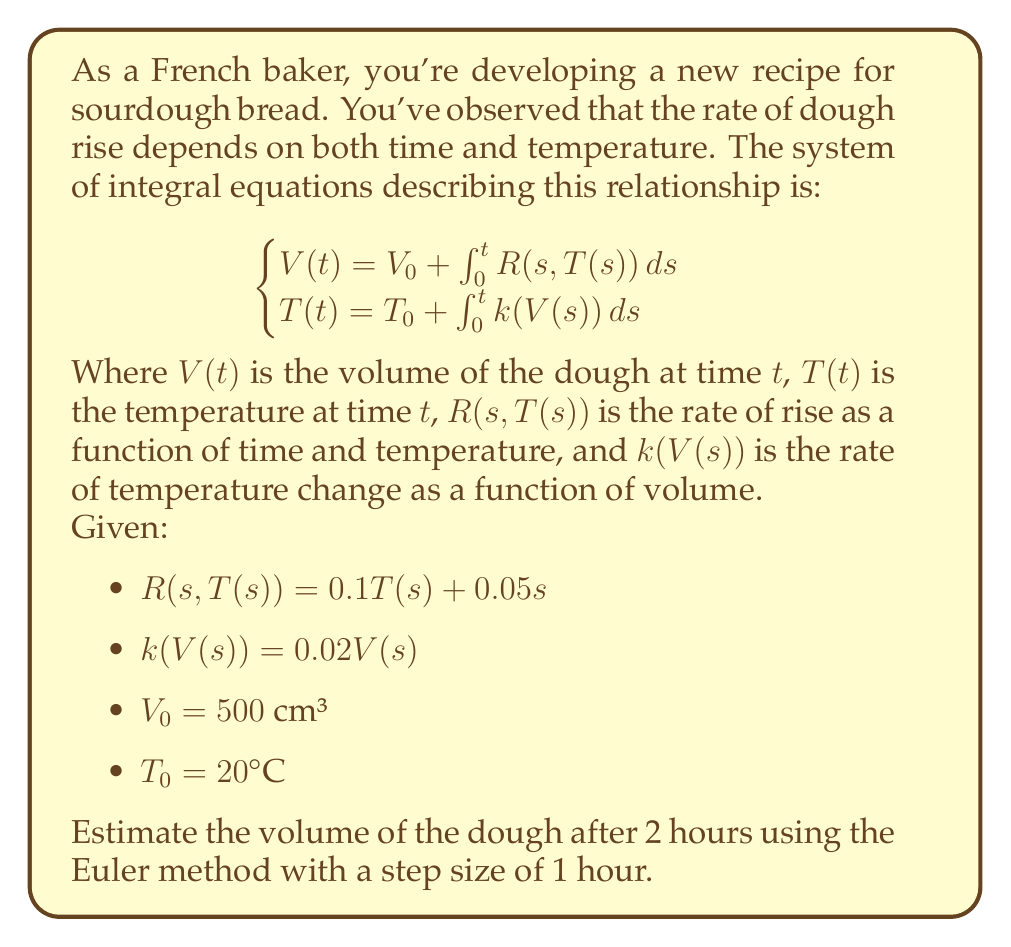Could you help me with this problem? To solve this problem, we'll use the Euler method to approximate the solution of the system of integral equations. We'll proceed step by step:

1) The Euler method for a system of equations takes the form:
   $$\begin{cases}
   V_{n+1} = V_n + h \cdot R(t_n, T_n) \\
   T_{n+1} = T_n + h \cdot k(V_n)
   \end{cases}$$
   where $h$ is the step size (1 hour in this case).

2) We start with the initial conditions:
   $V_0 = 500$ cm³
   $T_0 = 20°C$

3) For the first step ($n = 0$, $t = 0$ to $t = 1$):
   $$\begin{align*}
   V_1 &= V_0 + h \cdot R(0, T_0) \\
       &= 500 + 1 \cdot (0.1 \cdot 20 + 0.05 \cdot 0) \\
       &= 500 + 2 = 502 \text{ cm³}
   \end{align*}$$

   $$\begin{align*}
   T_1 &= T_0 + h \cdot k(V_0) \\
       &= 20 + 1 \cdot (0.02 \cdot 500) \\
       &= 20 + 10 = 30°C
   \end{align*}$$

4) For the second step ($n = 1$, $t = 1$ to $t = 2$):
   $$\begin{align*}
   V_2 &= V_1 + h \cdot R(1, T_1) \\
       &= 502 + 1 \cdot (0.1 \cdot 30 + 0.05 \cdot 1) \\
       &= 502 + 3.05 = 505.05 \text{ cm³}
   \end{align*}$$

   $$\begin{align*}
   T_2 &= T_1 + h \cdot k(V_1) \\
       &= 30 + 1 \cdot (0.02 \cdot 502) \\
       &= 30 + 10.04 = 40.04°C
   \end{align*}$$

5) Therefore, after 2 hours, the estimated volume of the dough is approximately 505.05 cm³.
Answer: 505.05 cm³ 